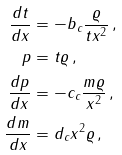<formula> <loc_0><loc_0><loc_500><loc_500>\frac { d t } { d x } & = - b _ { c } \frac { \varrho } { t x ^ { 2 } } \, , \\ p & = t \varrho \, , \\ \frac { d p } { d x } & = - c _ { c } \frac { m \varrho } { x ^ { 2 } } \, , \\ \frac { d m } { d x } & = d _ { c } x ^ { 2 } \varrho \, ,</formula> 